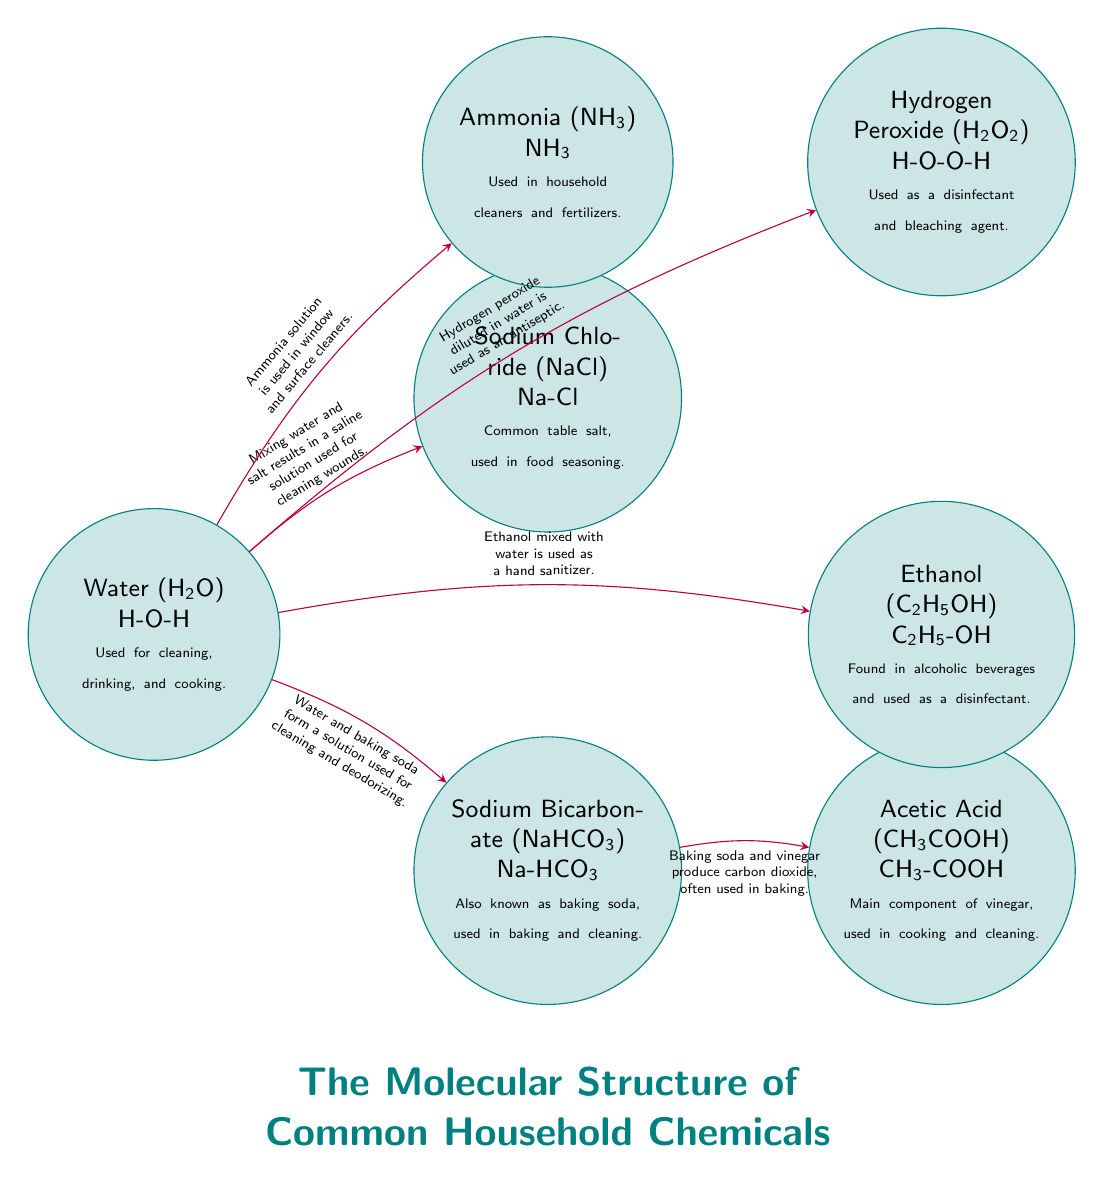What is the chemical formula of water? The diagram shows "Water (H2O)" indicated at the node representing water. The chemical formula is specified just below the name.
Answer: H2O How many household chemicals are represented in the diagram? By counting the nodes in the diagram, there are seven distinct nodes, each representing a different household chemical.
Answer: 7 What is one practical application of sodium bicarbonate? Looking at the node for Sodium Bicarbonate (NaHCO3), it states that it is "used in baking and cleaning", which shows its applications.
Answer: Baking and cleaning What do baking soda and vinegar produce when mixed? The diagram specifies that mixing baking soda (NaHCO3) with vinegar (CH3COOH) produces carbon dioxide, representing a chemical reaction relevant to baking.
Answer: Carbon dioxide What is the connection between water and ammonia? The diagram indicates that when water is mixed with ammonia (NH3), it is used in "window and surface cleaners", showing their relationship and use case together.
Answer: Window and surface cleaners What do hydrogen peroxide and water form when mixed? The connection in the diagram states that when hydrogen peroxide (H2O2) is diluted in water, it is used as an "antiseptic", which is an important household use.
Answer: Antiseptic What is the main use of ethanol? Referring to the ethanol (C2H5OH) node, it is mentioned that it is used as "a disinfectant", which directly indicates its primary application.
Answer: A disinfectant What is the relationship between water and sodium chloride? The diagram illustrates that mixing water (H2O) and sodium chloride (NaCl) results in a saline solution "used for cleaning wounds", showing how these substances interact.
Answer: Saline solution used for cleaning wounds What does the diagram use to describe acetic acid? The node labeled Acetic Acid (CH3COOH) outlines its use case as "Main component of vinegar", which identifies its practical application in a household context.
Answer: Main component of vinegar 